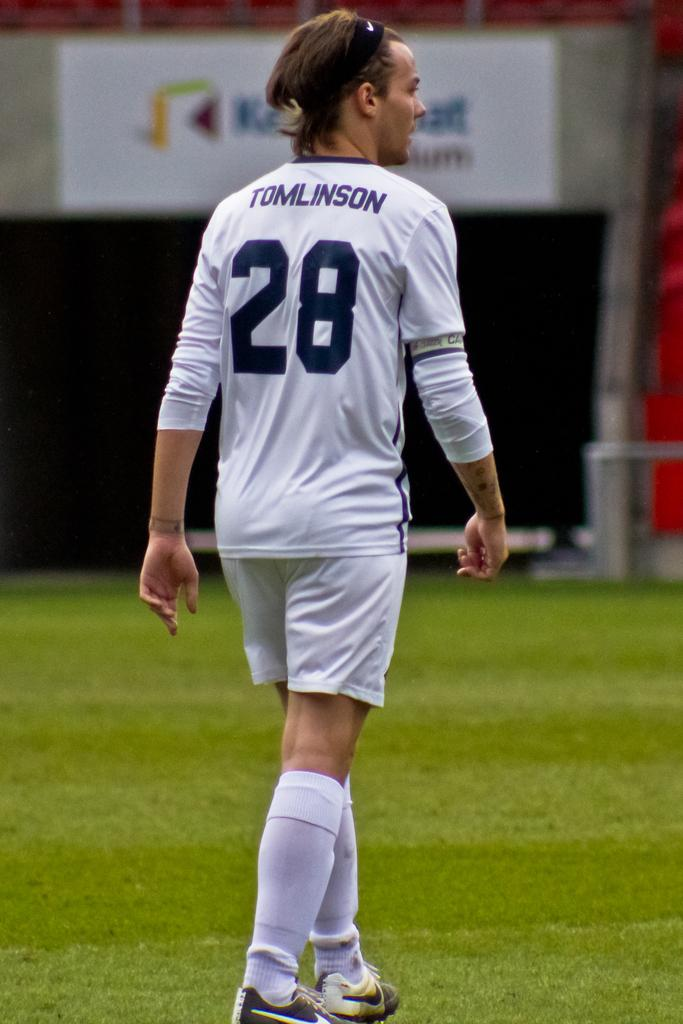What is the person in the image doing? There is a person walking in the image. What type of terrain is in front of the person? There is grass in front of the person. What is blocking the person's path? There is fencing in front of the person. What can be seen in the distance in the image? There is a stadium visible in the image. What is written on the fencing? There is a banner on the fencing. What type of plantation can be seen in the background of the image? There is no plantation present in the image; it features a person walking, grass, fencing, a stadium, and a banner on the fencing. Can you see a pipe in the person's hand in the image? There is no pipe visible in the person's hand in the image. 